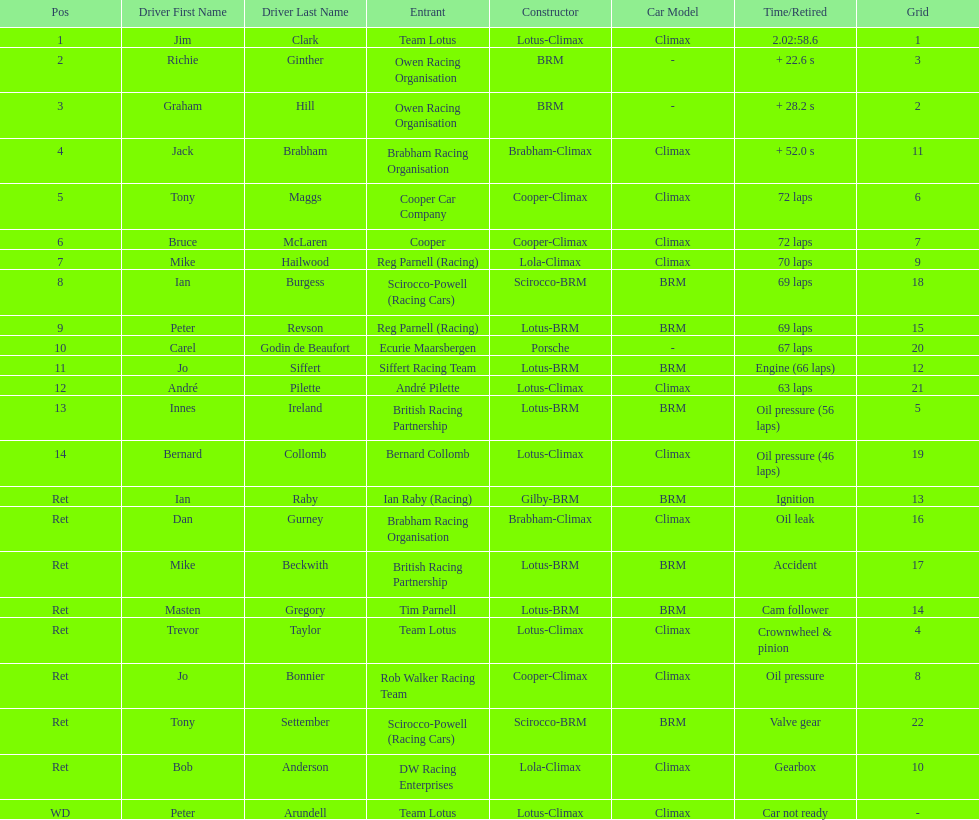What is the number of americans in the top 5? 1. Could you help me parse every detail presented in this table? {'header': ['Pos', 'Driver First Name', 'Driver Last Name', 'Entrant', 'Constructor', 'Car Model', 'Time/Retired', 'Grid'], 'rows': [['1', 'Jim', 'Clark', 'Team Lotus', 'Lotus-Climax', 'Climax', '2.02:58.6', '1'], ['2', 'Richie', 'Ginther', 'Owen Racing Organisation', 'BRM', '-', '+ 22.6 s', '3'], ['3', 'Graham', 'Hill', 'Owen Racing Organisation', 'BRM', '-', '+ 28.2 s', '2'], ['4', 'Jack', 'Brabham', 'Brabham Racing Organisation', 'Brabham-Climax', 'Climax', '+ 52.0 s', '11'], ['5', 'Tony', 'Maggs', 'Cooper Car Company', 'Cooper-Climax', 'Climax', '72 laps', '6'], ['6', 'Bruce', 'McLaren', 'Cooper', 'Cooper-Climax', 'Climax', '72 laps', '7'], ['7', 'Mike', 'Hailwood', 'Reg Parnell (Racing)', 'Lola-Climax', 'Climax', '70 laps', '9'], ['8', 'Ian', 'Burgess', 'Scirocco-Powell (Racing Cars)', 'Scirocco-BRM', 'BRM', '69 laps', '18'], ['9', 'Peter', 'Revson', 'Reg Parnell (Racing)', 'Lotus-BRM', 'BRM', '69 laps', '15'], ['10', 'Carel', 'Godin de Beaufort', 'Ecurie Maarsbergen', 'Porsche', '-', '67 laps', '20'], ['11', 'Jo', 'Siffert', 'Siffert Racing Team', 'Lotus-BRM', 'BRM', 'Engine (66 laps)', '12'], ['12', 'André', 'Pilette', 'André Pilette', 'Lotus-Climax', 'Climax', '63 laps', '21'], ['13', 'Innes', 'Ireland', 'British Racing Partnership', 'Lotus-BRM', 'BRM', 'Oil pressure (56 laps)', '5'], ['14', 'Bernard', 'Collomb', 'Bernard Collomb', 'Lotus-Climax', 'Climax', 'Oil pressure (46 laps)', '19'], ['Ret', 'Ian', 'Raby', 'Ian Raby (Racing)', 'Gilby-BRM', 'BRM', 'Ignition', '13'], ['Ret', 'Dan', 'Gurney', 'Brabham Racing Organisation', 'Brabham-Climax', 'Climax', 'Oil leak', '16'], ['Ret', 'Mike', 'Beckwith', 'British Racing Partnership', 'Lotus-BRM', 'BRM', 'Accident', '17'], ['Ret', 'Masten', 'Gregory', 'Tim Parnell', 'Lotus-BRM', 'BRM', 'Cam follower', '14'], ['Ret', 'Trevor', 'Taylor', 'Team Lotus', 'Lotus-Climax', 'Climax', 'Crownwheel & pinion', '4'], ['Ret', 'Jo', 'Bonnier', 'Rob Walker Racing Team', 'Cooper-Climax', 'Climax', 'Oil pressure', '8'], ['Ret', 'Tony', 'Settember', 'Scirocco-Powell (Racing Cars)', 'Scirocco-BRM', 'BRM', 'Valve gear', '22'], ['Ret', 'Bob', 'Anderson', 'DW Racing Enterprises', 'Lola-Climax', 'Climax', 'Gearbox', '10'], ['WD', 'Peter', 'Arundell', 'Team Lotus', 'Lotus-Climax', 'Climax', 'Car not ready', '-']]} 